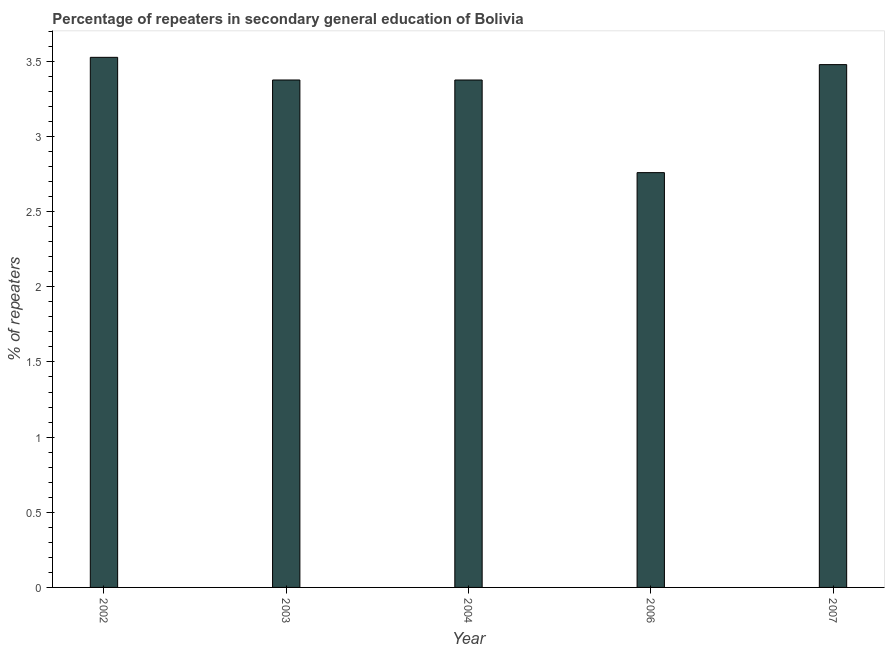What is the title of the graph?
Your answer should be compact. Percentage of repeaters in secondary general education of Bolivia. What is the label or title of the Y-axis?
Your answer should be very brief. % of repeaters. What is the percentage of repeaters in 2007?
Make the answer very short. 3.48. Across all years, what is the maximum percentage of repeaters?
Give a very brief answer. 3.53. Across all years, what is the minimum percentage of repeaters?
Give a very brief answer. 2.76. In which year was the percentage of repeaters maximum?
Your answer should be compact. 2002. What is the sum of the percentage of repeaters?
Give a very brief answer. 16.51. What is the difference between the percentage of repeaters in 2003 and 2004?
Offer a very short reply. 0. What is the average percentage of repeaters per year?
Your answer should be very brief. 3.3. What is the median percentage of repeaters?
Offer a terse response. 3.38. In how many years, is the percentage of repeaters greater than 1.1 %?
Provide a short and direct response. 5. Do a majority of the years between 2006 and 2004 (inclusive) have percentage of repeaters greater than 0.8 %?
Your response must be concise. No. What is the ratio of the percentage of repeaters in 2004 to that in 2006?
Offer a very short reply. 1.22. What is the difference between the highest and the second highest percentage of repeaters?
Provide a short and direct response. 0.05. Is the sum of the percentage of repeaters in 2002 and 2007 greater than the maximum percentage of repeaters across all years?
Provide a succinct answer. Yes. What is the difference between the highest and the lowest percentage of repeaters?
Offer a terse response. 0.77. In how many years, is the percentage of repeaters greater than the average percentage of repeaters taken over all years?
Offer a terse response. 4. How many bars are there?
Offer a terse response. 5. How many years are there in the graph?
Provide a succinct answer. 5. Are the values on the major ticks of Y-axis written in scientific E-notation?
Your answer should be very brief. No. What is the % of repeaters of 2002?
Ensure brevity in your answer.  3.53. What is the % of repeaters of 2003?
Make the answer very short. 3.38. What is the % of repeaters of 2004?
Your answer should be very brief. 3.38. What is the % of repeaters of 2006?
Your answer should be very brief. 2.76. What is the % of repeaters of 2007?
Offer a terse response. 3.48. What is the difference between the % of repeaters in 2002 and 2003?
Offer a very short reply. 0.15. What is the difference between the % of repeaters in 2002 and 2004?
Your answer should be very brief. 0.15. What is the difference between the % of repeaters in 2002 and 2006?
Give a very brief answer. 0.77. What is the difference between the % of repeaters in 2002 and 2007?
Ensure brevity in your answer.  0.05. What is the difference between the % of repeaters in 2003 and 2004?
Provide a succinct answer. 4e-5. What is the difference between the % of repeaters in 2003 and 2006?
Keep it short and to the point. 0.62. What is the difference between the % of repeaters in 2003 and 2007?
Ensure brevity in your answer.  -0.1. What is the difference between the % of repeaters in 2004 and 2006?
Ensure brevity in your answer.  0.62. What is the difference between the % of repeaters in 2004 and 2007?
Offer a very short reply. -0.1. What is the difference between the % of repeaters in 2006 and 2007?
Provide a succinct answer. -0.72. What is the ratio of the % of repeaters in 2002 to that in 2003?
Your answer should be compact. 1.04. What is the ratio of the % of repeaters in 2002 to that in 2004?
Your response must be concise. 1.04. What is the ratio of the % of repeaters in 2002 to that in 2006?
Your answer should be very brief. 1.28. What is the ratio of the % of repeaters in 2003 to that in 2004?
Your answer should be very brief. 1. What is the ratio of the % of repeaters in 2003 to that in 2006?
Provide a short and direct response. 1.22. What is the ratio of the % of repeaters in 2004 to that in 2006?
Make the answer very short. 1.22. What is the ratio of the % of repeaters in 2004 to that in 2007?
Provide a short and direct response. 0.97. What is the ratio of the % of repeaters in 2006 to that in 2007?
Provide a short and direct response. 0.79. 